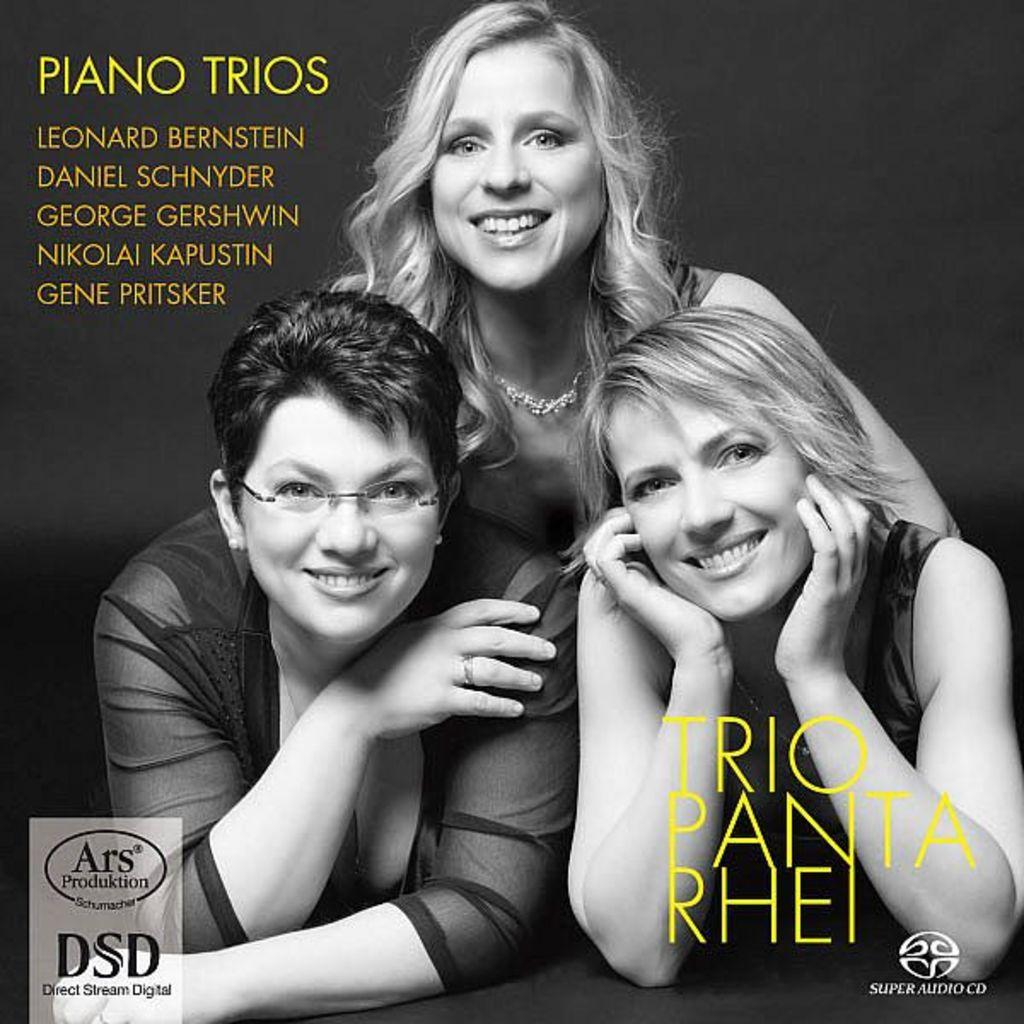What is present in the image? There is a poster in the image. What can be found on the poster? The poster contains text and an image of three persons. What type of trousers are the three persons wearing in the image? There are no trousers visible in the image, as the focus is on the poster and not the persons depicted in the image. 